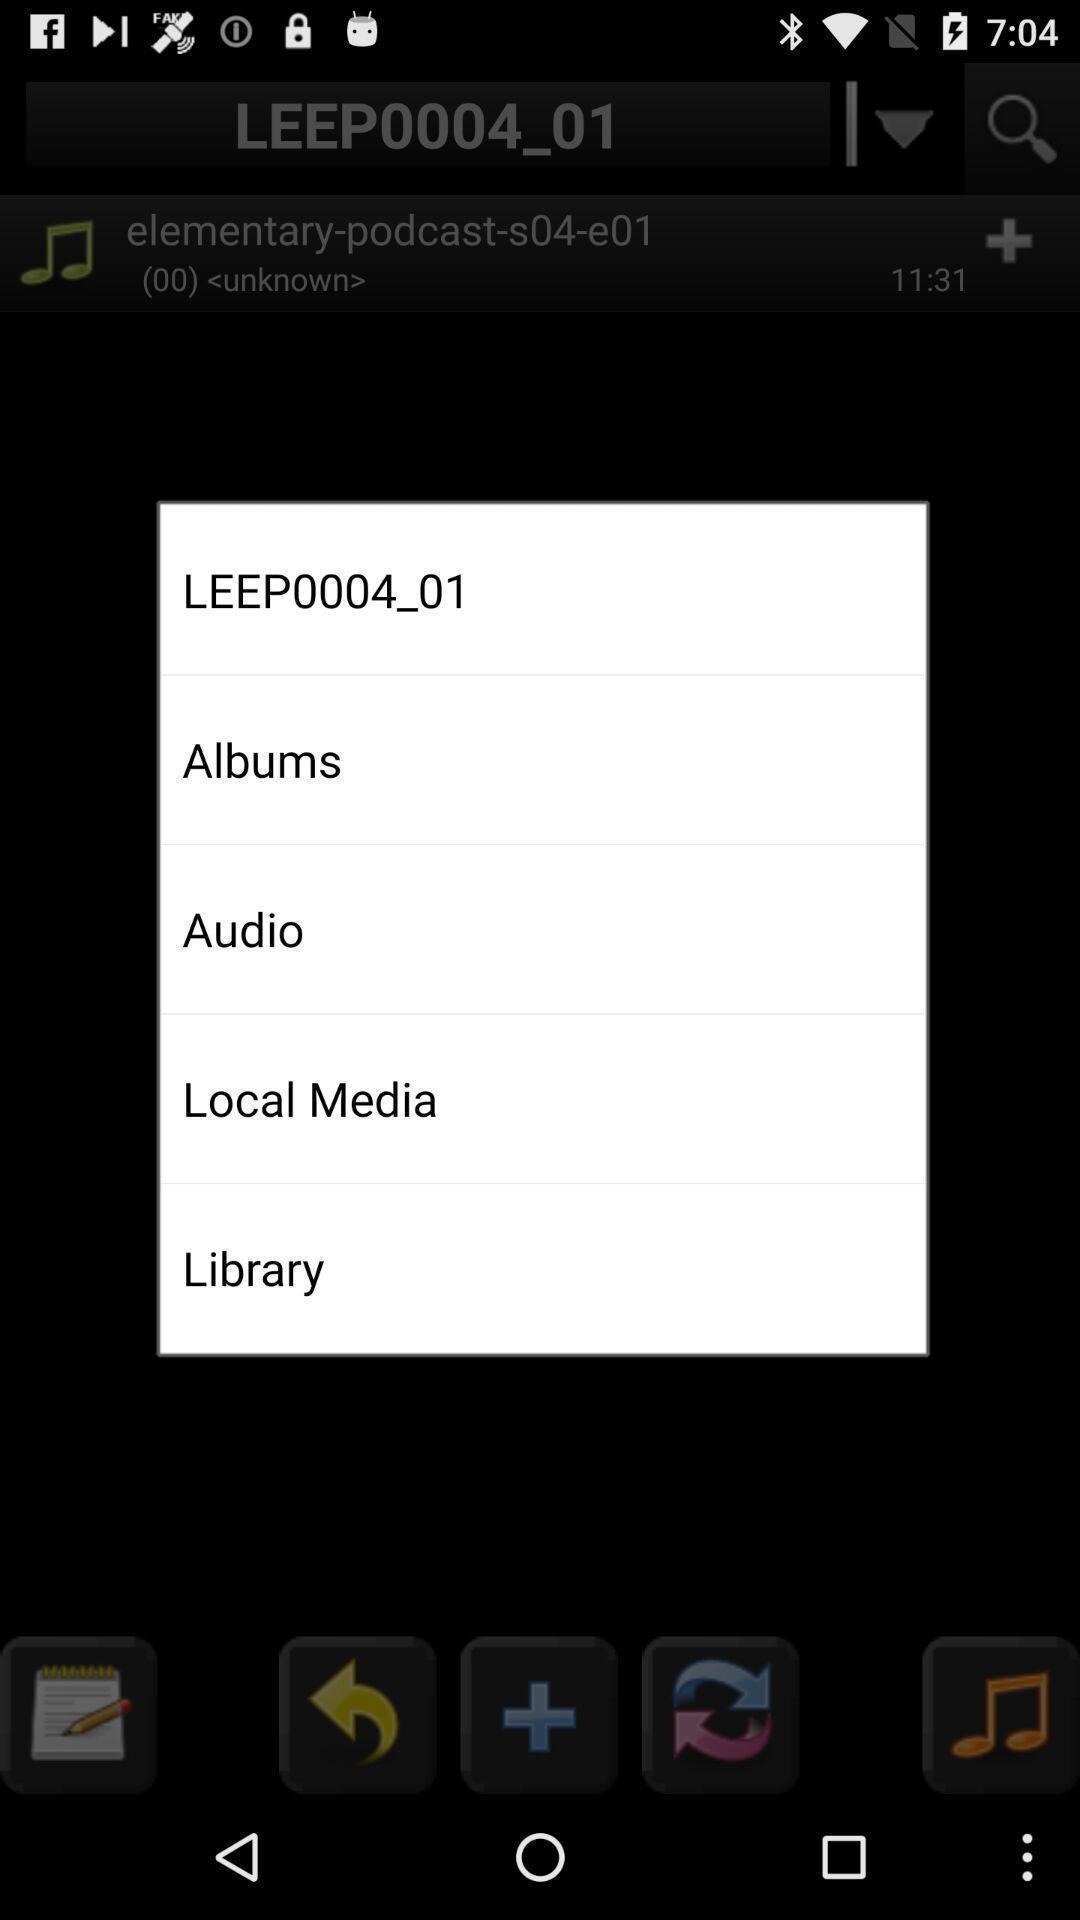What is the overall content of this screenshot? Pop-up shows different options. 